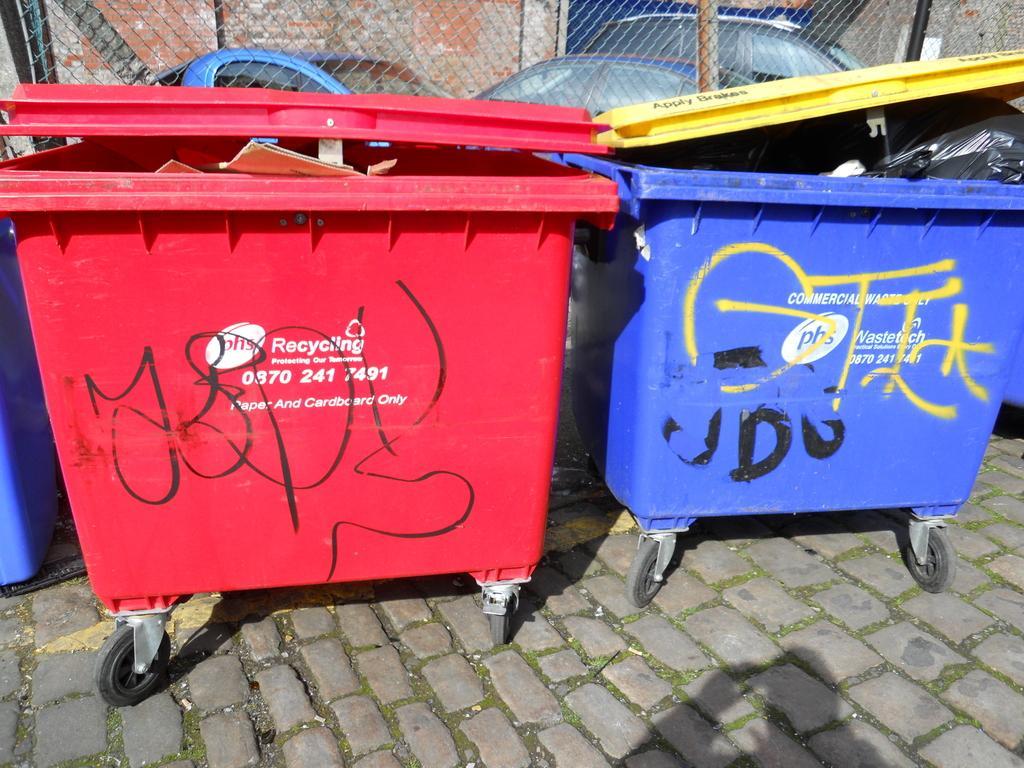Please provide a concise description of this image. In this image I can see there is a red color bin with a cap on the left side. On the right side there is a blue color bin, it has wheels also. At the top there is an iron net and there are few cars are parked at the back side of an image. 